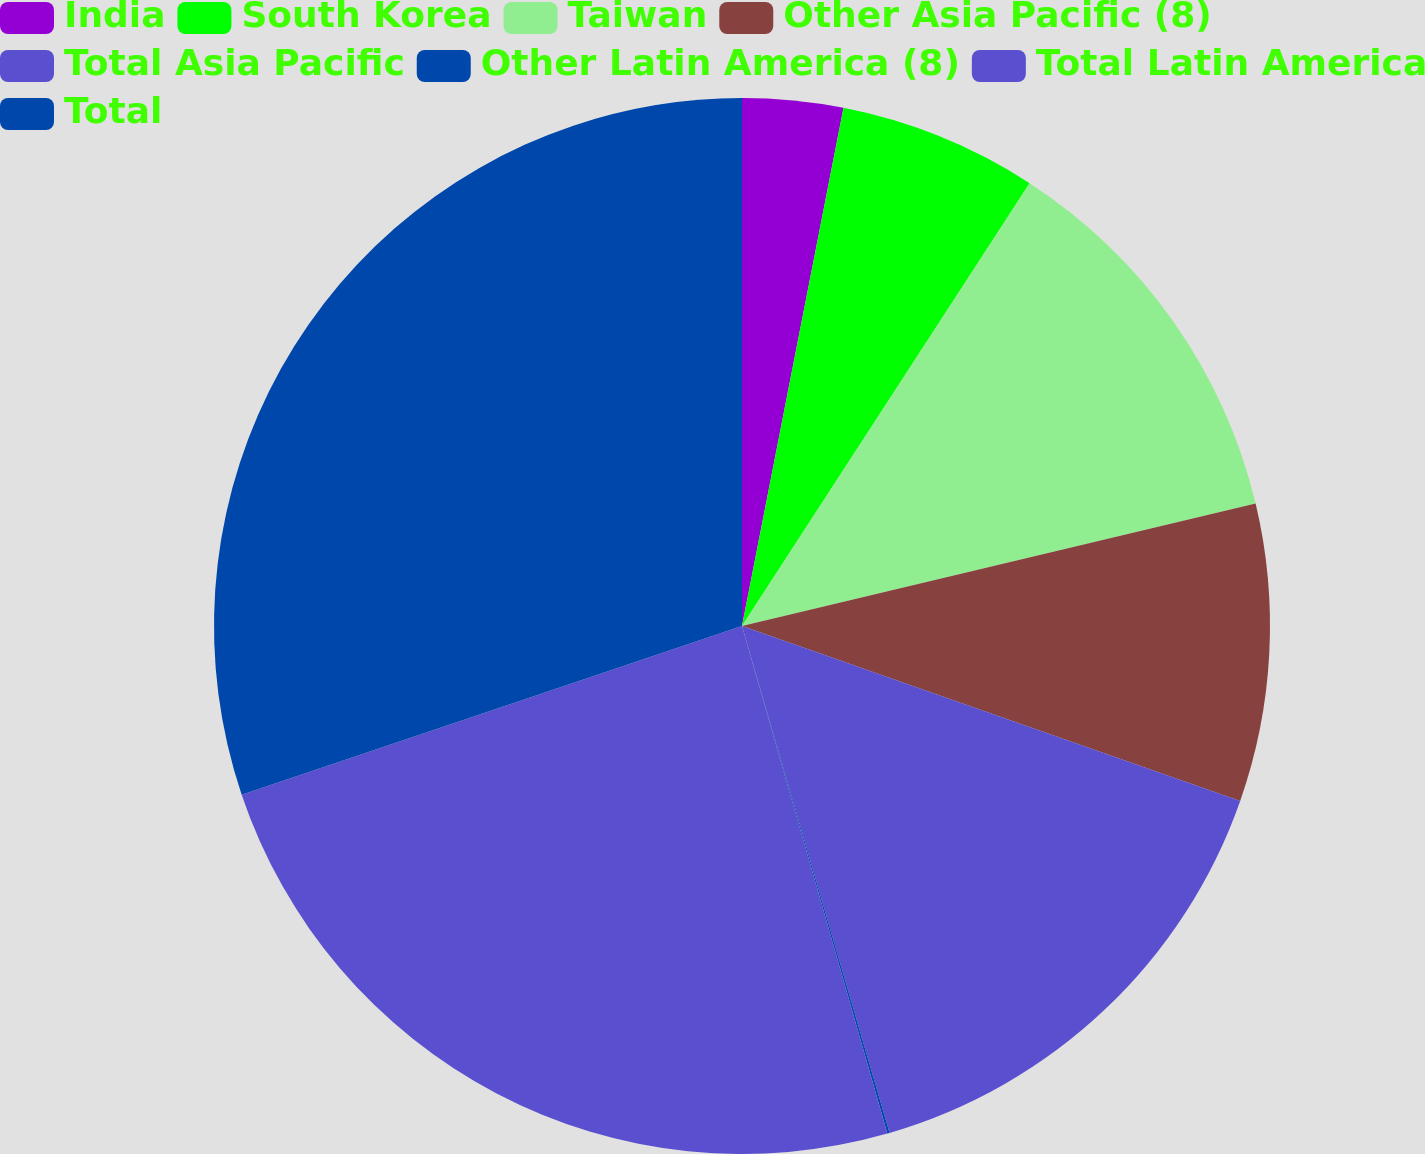Convert chart to OTSL. <chart><loc_0><loc_0><loc_500><loc_500><pie_chart><fcel>India<fcel>South Korea<fcel>Taiwan<fcel>Other Asia Pacific (8)<fcel>Total Asia Pacific<fcel>Other Latin America (8)<fcel>Total Latin America<fcel>Total<nl><fcel>3.08%<fcel>6.09%<fcel>12.11%<fcel>9.1%<fcel>15.12%<fcel>0.07%<fcel>24.27%<fcel>30.18%<nl></chart> 